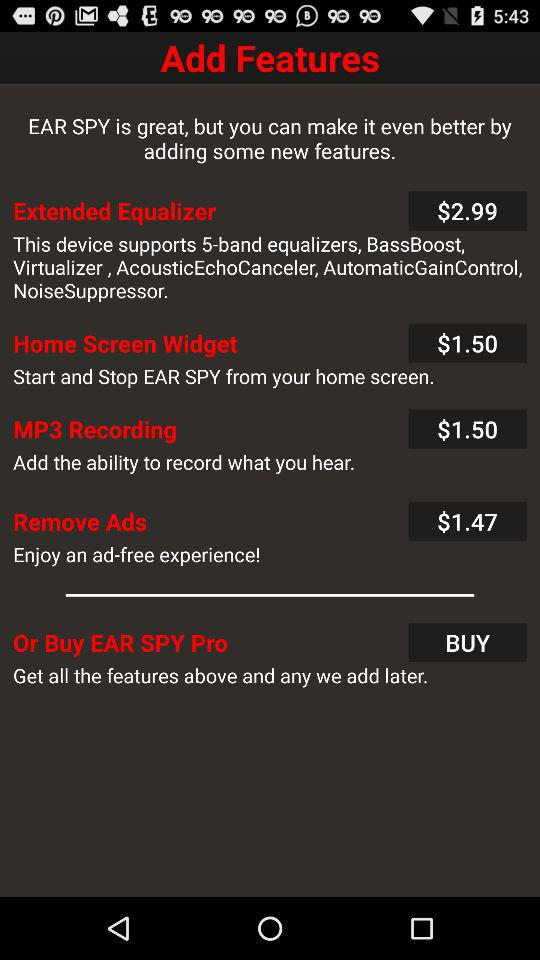What is the price of "Home Screen Widget"? The price of "Home Screen Widget" is $1.50. 